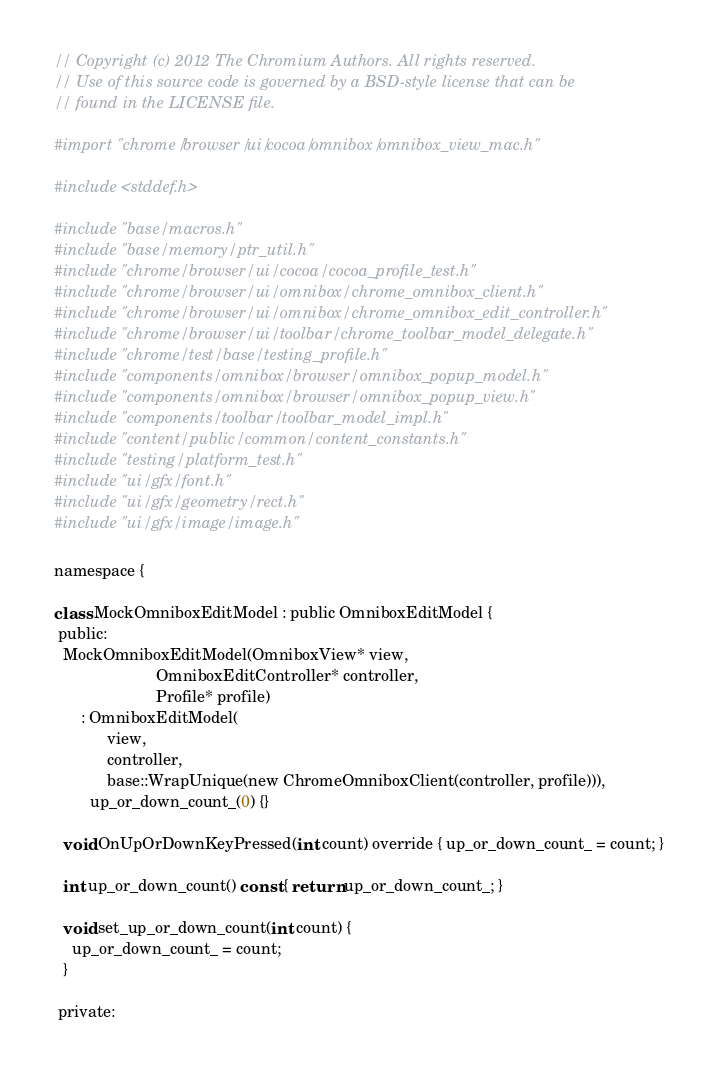Convert code to text. <code><loc_0><loc_0><loc_500><loc_500><_ObjectiveC_>// Copyright (c) 2012 The Chromium Authors. All rights reserved.
// Use of this source code is governed by a BSD-style license that can be
// found in the LICENSE file.

#import "chrome/browser/ui/cocoa/omnibox/omnibox_view_mac.h"

#include <stddef.h>

#include "base/macros.h"
#include "base/memory/ptr_util.h"
#include "chrome/browser/ui/cocoa/cocoa_profile_test.h"
#include "chrome/browser/ui/omnibox/chrome_omnibox_client.h"
#include "chrome/browser/ui/omnibox/chrome_omnibox_edit_controller.h"
#include "chrome/browser/ui/toolbar/chrome_toolbar_model_delegate.h"
#include "chrome/test/base/testing_profile.h"
#include "components/omnibox/browser/omnibox_popup_model.h"
#include "components/omnibox/browser/omnibox_popup_view.h"
#include "components/toolbar/toolbar_model_impl.h"
#include "content/public/common/content_constants.h"
#include "testing/platform_test.h"
#include "ui/gfx/font.h"
#include "ui/gfx/geometry/rect.h"
#include "ui/gfx/image/image.h"

namespace {

class MockOmniboxEditModel : public OmniboxEditModel {
 public:
  MockOmniboxEditModel(OmniboxView* view,
                       OmniboxEditController* controller,
                       Profile* profile)
      : OmniboxEditModel(
            view,
            controller,
            base::WrapUnique(new ChromeOmniboxClient(controller, profile))),
        up_or_down_count_(0) {}

  void OnUpOrDownKeyPressed(int count) override { up_or_down_count_ = count; }

  int up_or_down_count() const { return up_or_down_count_; }

  void set_up_or_down_count(int count) {
    up_or_down_count_ = count;
  }

 private:</code> 